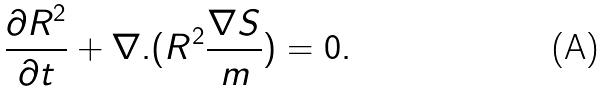Convert formula to latex. <formula><loc_0><loc_0><loc_500><loc_500>\frac { \partial R ^ { 2 } } { \partial t } + \nabla . ( R ^ { 2 } \frac { \nabla S } { m } ) = 0 .</formula> 